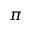Convert formula to latex. <formula><loc_0><loc_0><loc_500><loc_500>\pi</formula> 